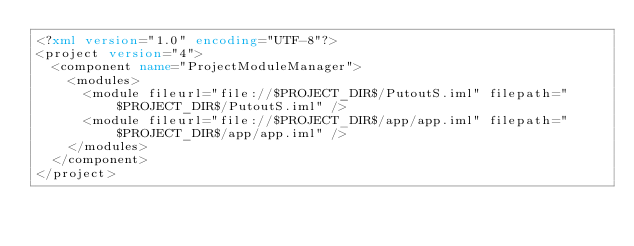<code> <loc_0><loc_0><loc_500><loc_500><_XML_><?xml version="1.0" encoding="UTF-8"?>
<project version="4">
  <component name="ProjectModuleManager">
    <modules>
      <module fileurl="file://$PROJECT_DIR$/PutoutS.iml" filepath="$PROJECT_DIR$/PutoutS.iml" />
      <module fileurl="file://$PROJECT_DIR$/app/app.iml" filepath="$PROJECT_DIR$/app/app.iml" />
    </modules>
  </component>
</project></code> 